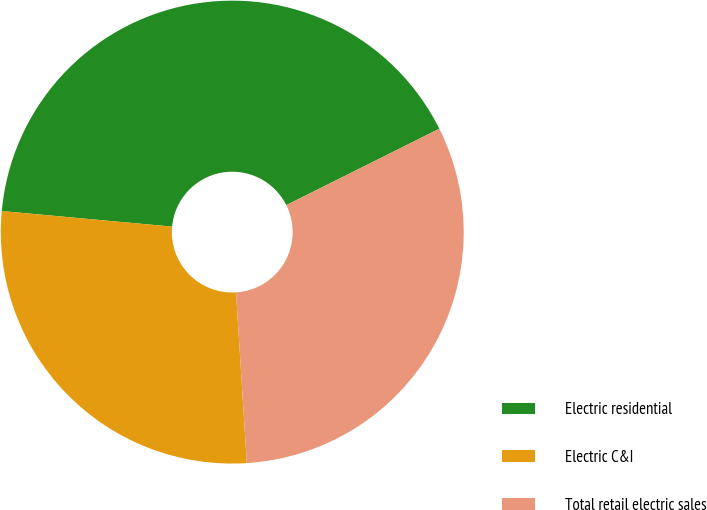Convert chart to OTSL. <chart><loc_0><loc_0><loc_500><loc_500><pie_chart><fcel>Electric residential<fcel>Electric C&I<fcel>Total retail electric sales<nl><fcel>41.18%<fcel>27.45%<fcel>31.37%<nl></chart> 